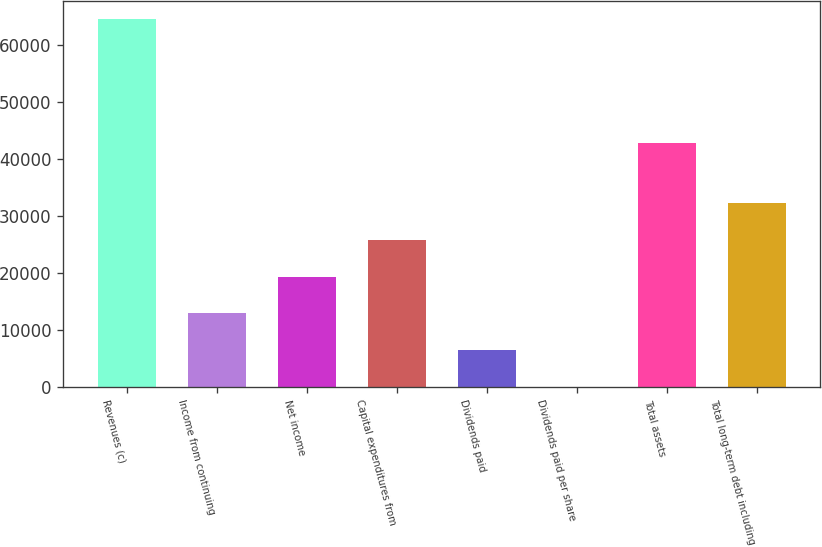<chart> <loc_0><loc_0><loc_500><loc_500><bar_chart><fcel>Revenues (c)<fcel>Income from continuing<fcel>Net income<fcel>Capital expenditures from<fcel>Dividends paid<fcel>Dividends paid per share<fcel>Total assets<fcel>Total long-term debt including<nl><fcel>64552<fcel>12911.1<fcel>19366.2<fcel>25821.4<fcel>6456.03<fcel>0.92<fcel>42746<fcel>32276.5<nl></chart> 